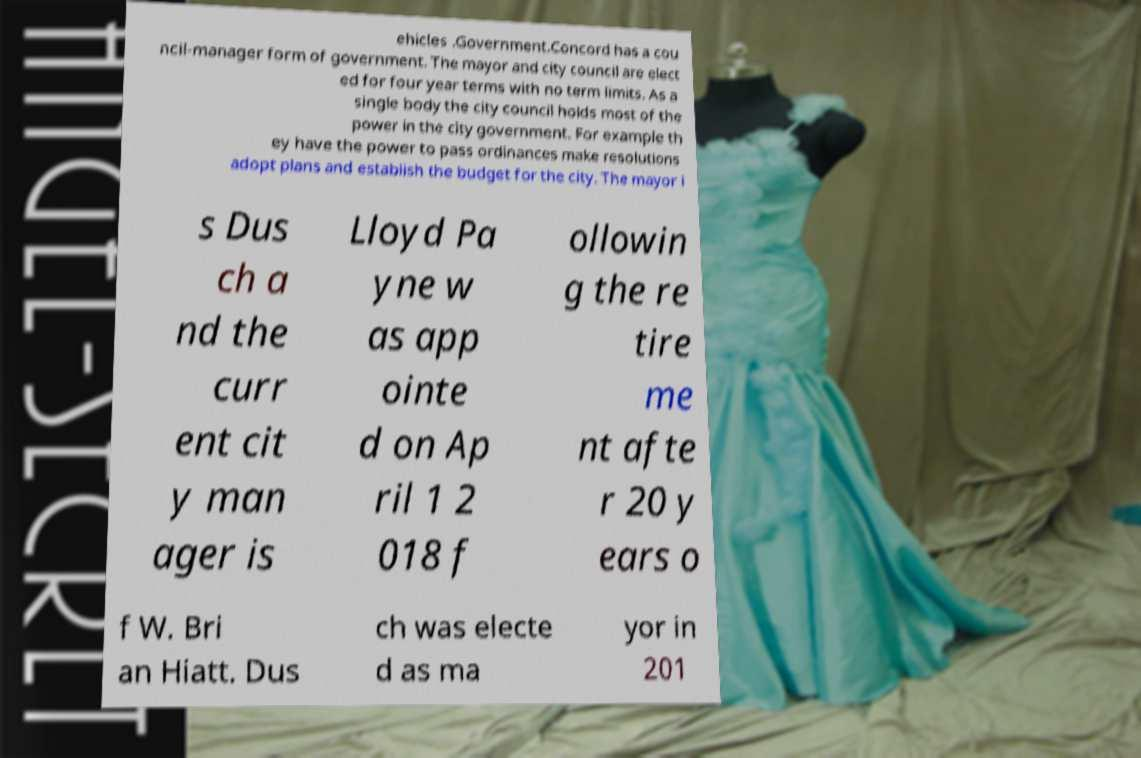What messages or text are displayed in this image? I need them in a readable, typed format. ehicles .Government.Concord has a cou ncil-manager form of government. The mayor and city council are elect ed for four year terms with no term limits. As a single body the city council holds most of the power in the city government. For example th ey have the power to pass ordinances make resolutions adopt plans and establish the budget for the city. The mayor i s Dus ch a nd the curr ent cit y man ager is Lloyd Pa yne w as app ointe d on Ap ril 1 2 018 f ollowin g the re tire me nt afte r 20 y ears o f W. Bri an Hiatt. Dus ch was electe d as ma yor in 201 